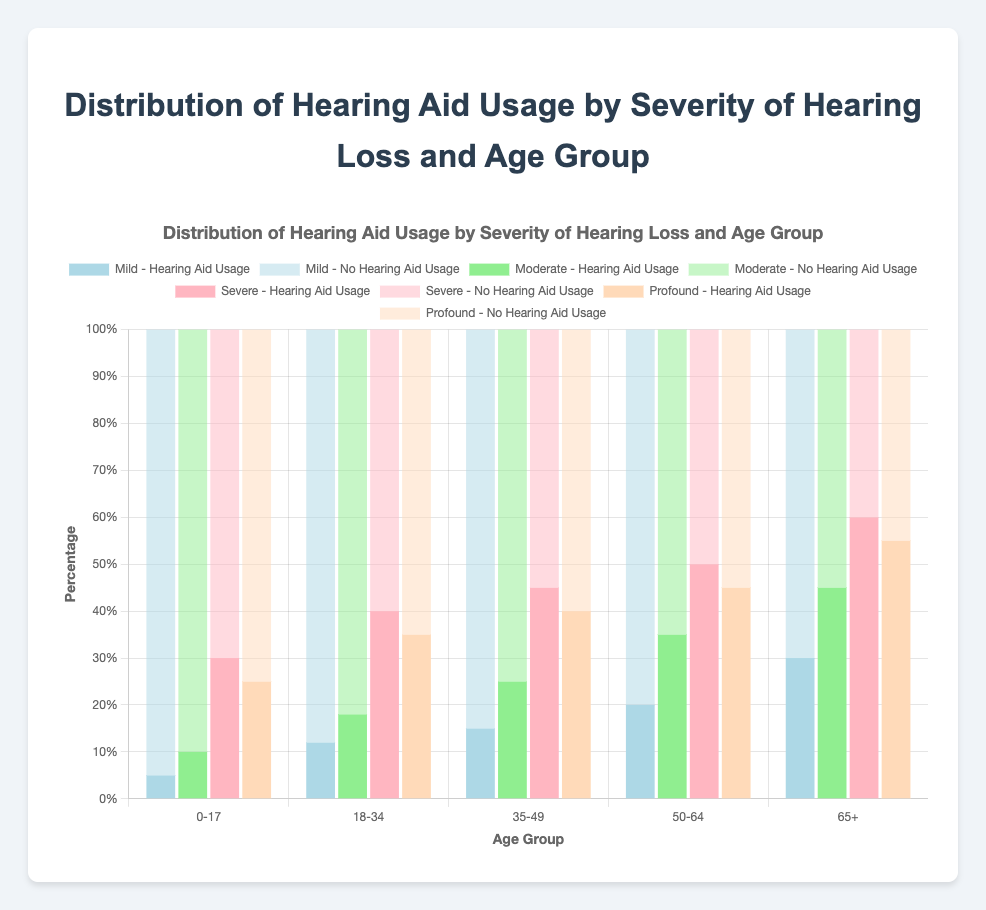Which age group has the highest hearing aid usage for profound hearing loss? To determine this, look for the age group with the tallest bar segment for profound hearing loss hearing aid usage. The 65+ age group has the highest segment.
Answer: 65+ What's the difference in hearing aid usage between mild and severe hearing loss in the 50-64 age group? Subtract the hearing aid usage percentage of mild hearing loss from that of severe hearing loss within the 50-64 age group. Severe: 50% - Mild: 20% gives the difference.
Answer: 30% What is the average hearing aid usage percentage across all age groups for moderate hearing loss? Sum the hearing aid usage percentages for moderate hearing loss across all age groups and divide by the number of age groups: (10 + 18 + 25 + 35 + 45) / 5 = 133/5.
Answer: 27% Which severity of hearing loss sees the least variance in hearing aid usage across all age groups? Compare the range (max-min) of hearing aid usage percentages for each severity across all age groups. Mild has the smallest range with max usage at 30% and min at 5%.
Answer: Mild Is hearing aid usage always higher for severe hearing loss compared to mild hearing loss across all age groups? Compare the hearing aid usage percentages of severe hearing loss to mild hearing loss within each age group. In all groups, severe hearing loss has higher percentages than mild.
Answer: Yes What is the total hearing aid usage for moderate hearing loss in the 18-34 and 35-49 age groups combined? Add the hearing aid usage percentages for moderate hearing loss in the 18-34 and 35-49 age groups: 18% + 25%.
Answer: 43% In which age group is the gap between hearing aid usage and no hearing aid usage for profound hearing loss the smallest? Subtract the hearing aid usage percentage from the no hearing aid usage percentage for profound hearing loss in each age group and find the smallest result. The 65+ age group has the smallest gap: 55% - 45%.
Answer: 65+ How does hearing aid usage for severe hearing loss in the 35-49 age group compare to that in the 50-64 age group? Compare the percentages: 35-49 age group has 45% and 50-64 age group has 50%.
Answer: 50-64 is higher 